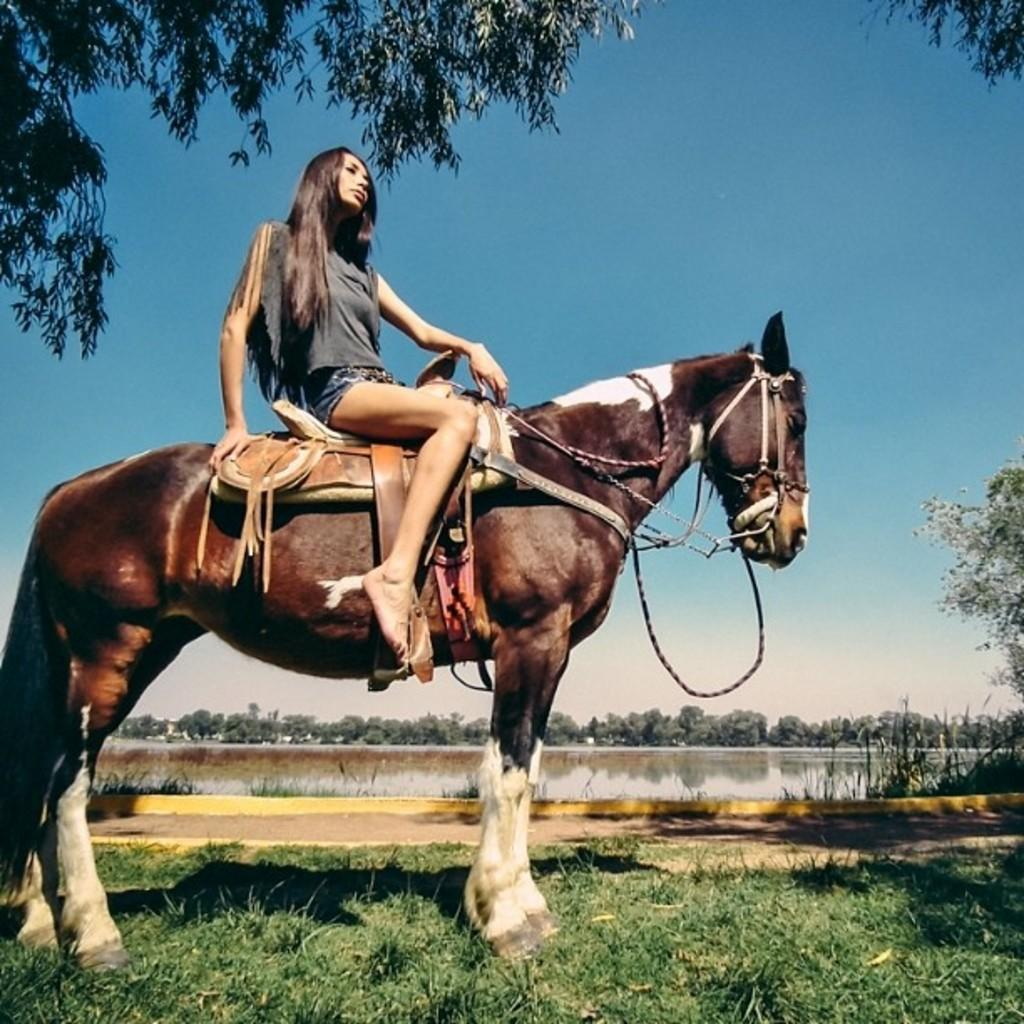What is the main subject of the image? There is a person in the image. What activity is the person engaged in? The person is doing horse riding. What can be seen in the background of the image? There are trees and the sky visible in the background of the image. What type of advertisement can be seen on the person's jeans in the image? There is no advertisement visible on the person's jeans in the image, as the facts provided do not mention any advertisement or jeans. 